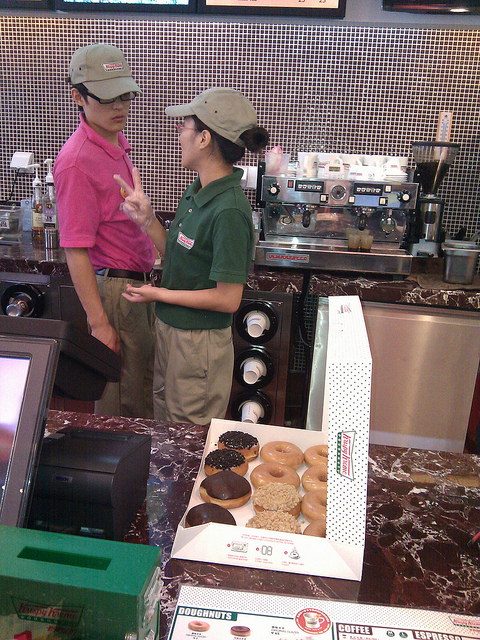Identify and read out the text in this image. 08 DOUGHNUTS 